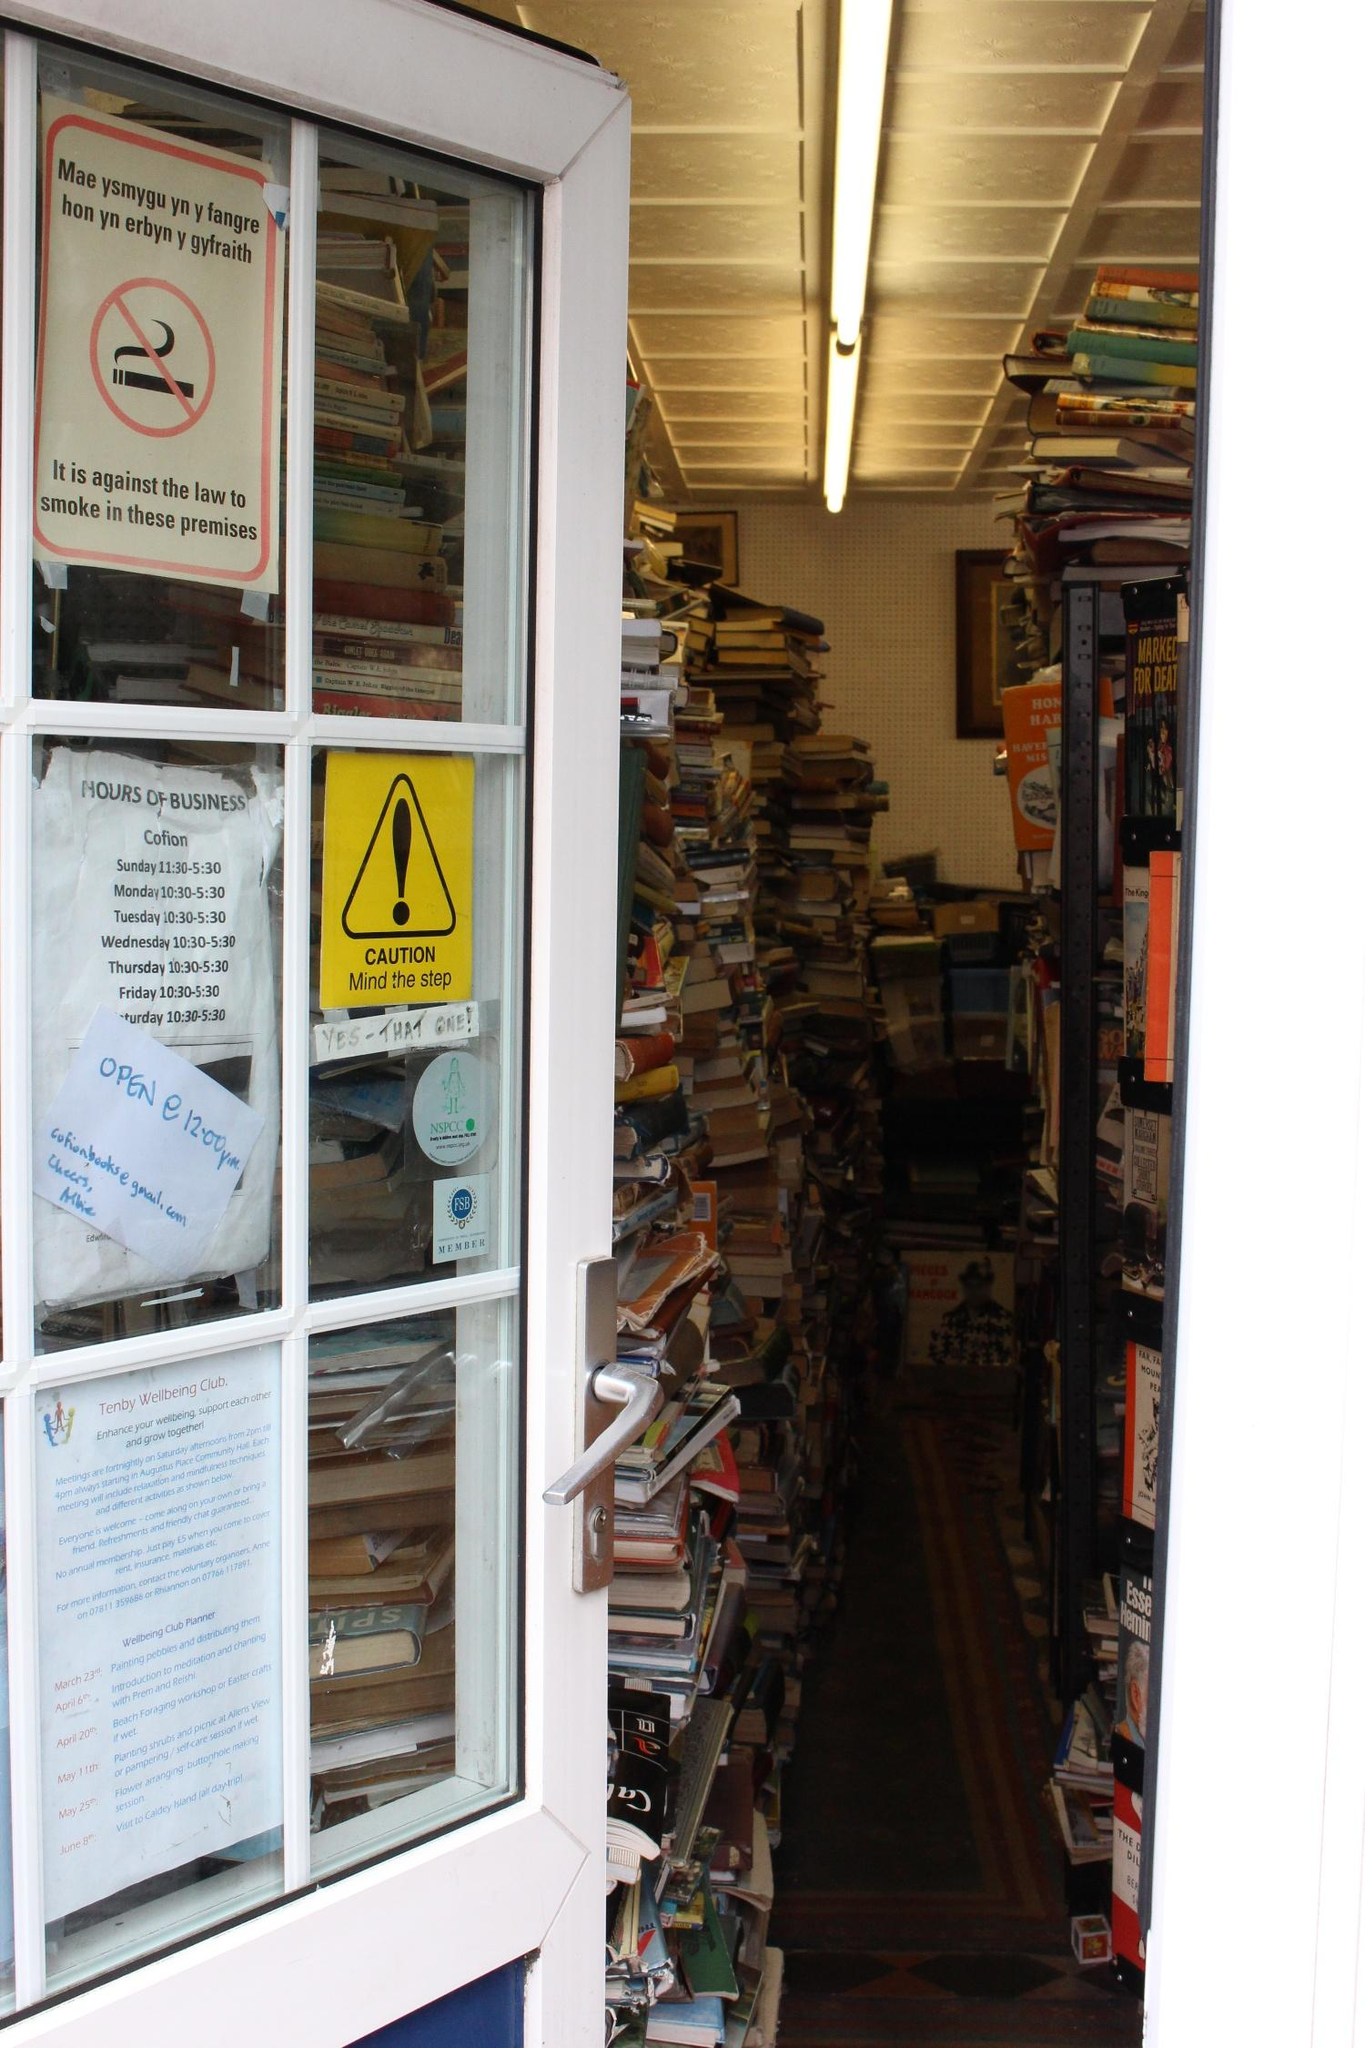Analyze the image in a comprehensive and detailed manner.
 The image presents a view of a bookstore, captured from outside through a window framed in white. The window is adorned with several signs, adding a touch of character to the scene. Inside, the store is a bibliophile's dream, with stacks of books lining the wooden shelves. The books, varying in colors and sizes, create a vibrant mosaic of knowledge waiting to be explored. Despite the apparent clutter, there's a sense of organized chaos, a testament to the many stories and ideas housed within the store. A sign in the window indicates a smoking ban, reminding visitors to respect the sanctity of this literary sanctuary. The overall scene paints a picture of a cozy, inviting space, a haven for those seeking solace in the written word. 